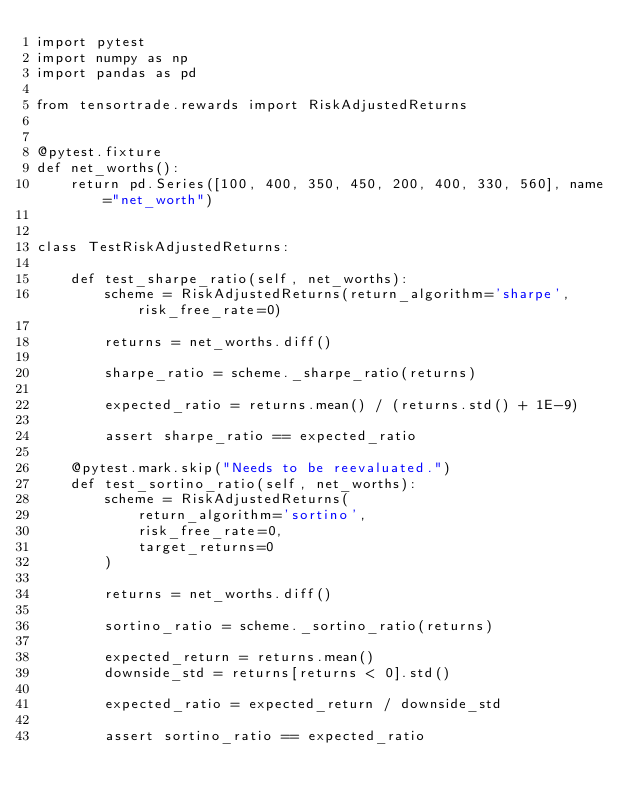Convert code to text. <code><loc_0><loc_0><loc_500><loc_500><_Python_>import pytest
import numpy as np
import pandas as pd

from tensortrade.rewards import RiskAdjustedReturns


@pytest.fixture
def net_worths():
    return pd.Series([100, 400, 350, 450, 200, 400, 330, 560], name="net_worth")


class TestRiskAdjustedReturns:

    def test_sharpe_ratio(self, net_worths):
        scheme = RiskAdjustedReturns(return_algorithm='sharpe', risk_free_rate=0)

        returns = net_worths.diff()

        sharpe_ratio = scheme._sharpe_ratio(returns)

        expected_ratio = returns.mean() / (returns.std() + 1E-9)

        assert sharpe_ratio == expected_ratio

    @pytest.mark.skip("Needs to be reevaluated.")
    def test_sortino_ratio(self, net_worths):
        scheme = RiskAdjustedReturns(
            return_algorithm='sortino',
            risk_free_rate=0,
            target_returns=0
        )

        returns = net_worths.diff()

        sortino_ratio = scheme._sortino_ratio(returns)

        expected_return = returns.mean()
        downside_std = returns[returns < 0].std()

        expected_ratio = expected_return / downside_std

        assert sortino_ratio == expected_ratio
</code> 